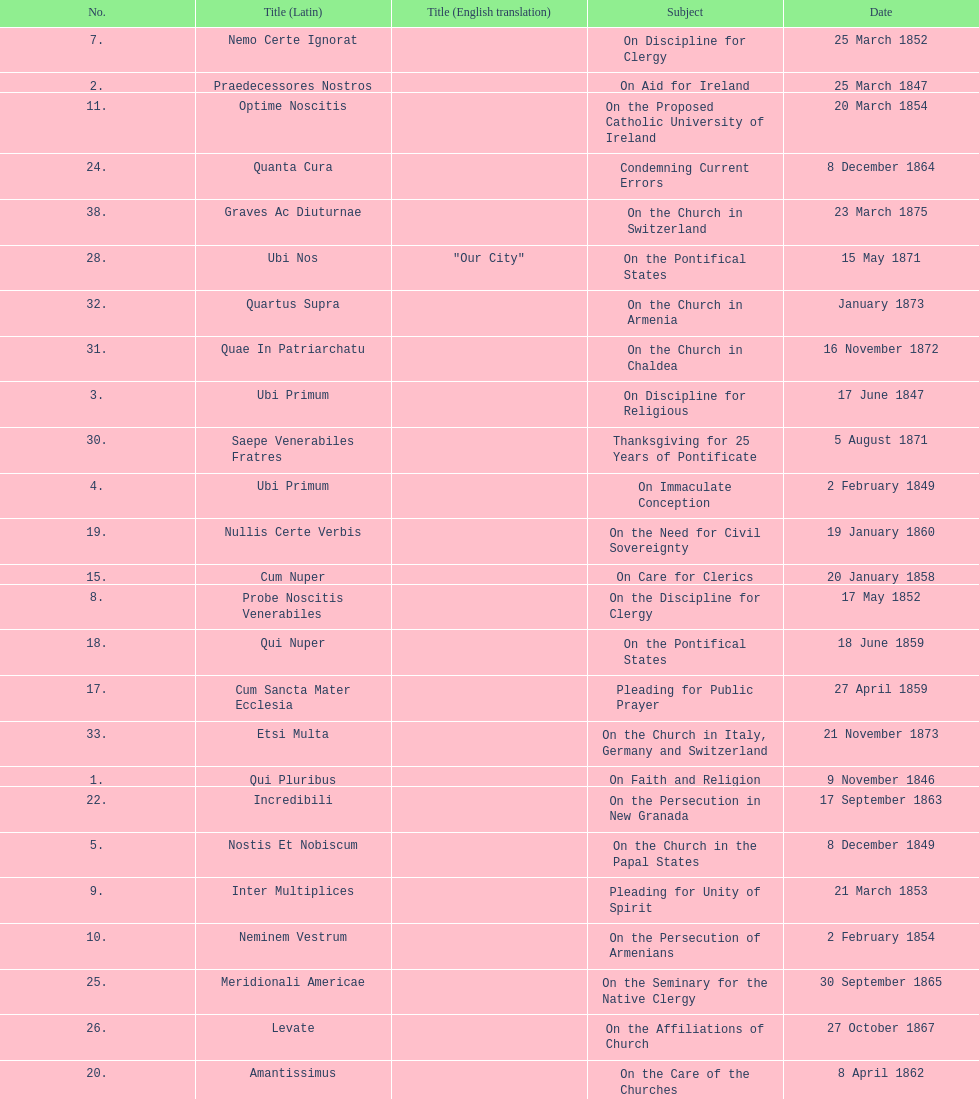How many encyclicals were issued between august 15, 1854 and october 26, 1867? 13. 